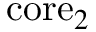Convert formula to latex. <formula><loc_0><loc_0><loc_500><loc_500>c o r e _ { 2 }</formula> 